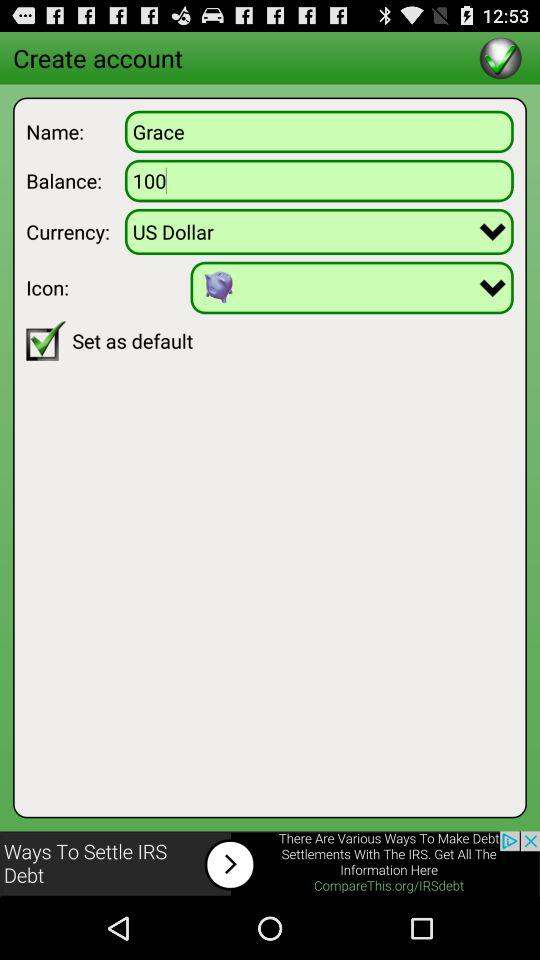How much balance is showing? The balance is 100. 